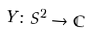<formula> <loc_0><loc_0><loc_500><loc_500>Y \colon S ^ { 2 } \to \mathbb { C }</formula> 